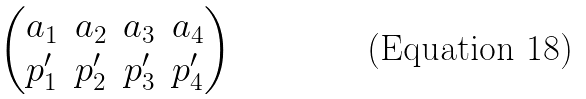Convert formula to latex. <formula><loc_0><loc_0><loc_500><loc_500>\begin{pmatrix} a _ { 1 } & a _ { 2 } & a _ { 3 } & a _ { 4 } \\ p _ { 1 } ^ { \prime } & p _ { 2 } ^ { \prime } & p _ { 3 } ^ { \prime } & p _ { 4 } ^ { \prime } \\ \end{pmatrix}</formula> 